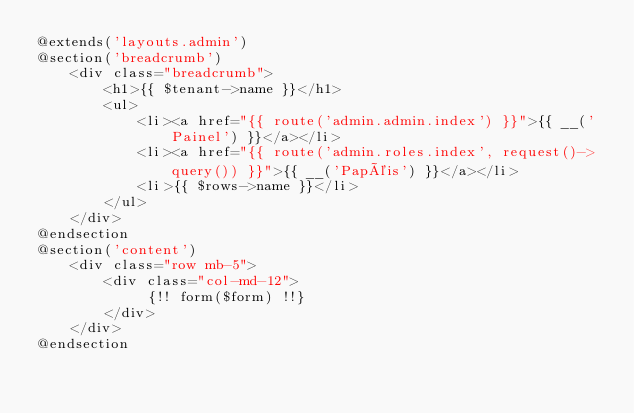Convert code to text. <code><loc_0><loc_0><loc_500><loc_500><_PHP_>@extends('layouts.admin')
@section('breadcrumb')
    <div class="breadcrumb">
        <h1>{{ $tenant->name }}</h1>
        <ul>
            <li><a href="{{ route('admin.admin.index') }}">{{ __('Painel') }}</a></li>
            <li><a href="{{ route('admin.roles.index', request()->query()) }}">{{ __('Papéis') }}</a></li>
            <li>{{ $rows->name }}</li>
        </ul>
    </div>
@endsection
@section('content')
    <div class="row mb-5">
        <div class="col-md-12">
             {!! form($form) !!}
        </div>
    </div>
@endsection


</code> 